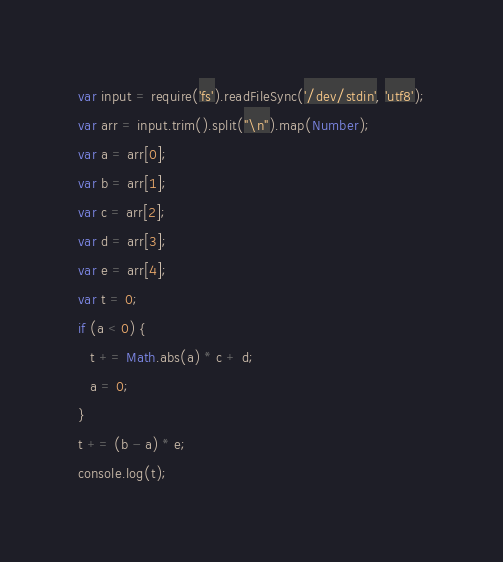Convert code to text. <code><loc_0><loc_0><loc_500><loc_500><_JavaScript_>var input = require('fs').readFileSync('/dev/stdin', 'utf8');
var arr = input.trim().split("\n").map(Number);
var a = arr[0];
var b = arr[1];
var c = arr[2];
var d = arr[3];
var e = arr[4];
var t = 0;
if (a < 0) {
   t += Math.abs(a) * c + d;
   a = 0;
}
t += (b - a) * e;
console.log(t);</code> 